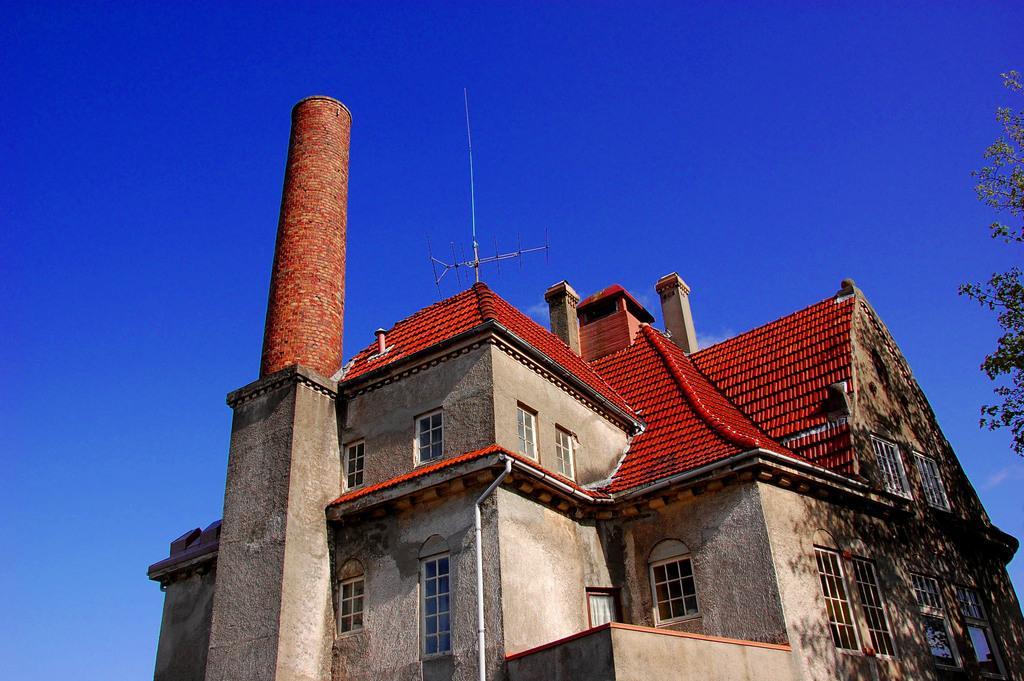How would you summarize this image in a sentence or two? In this picture we can see a building, where we can see an antenna, tree and we can see sky in the background. 